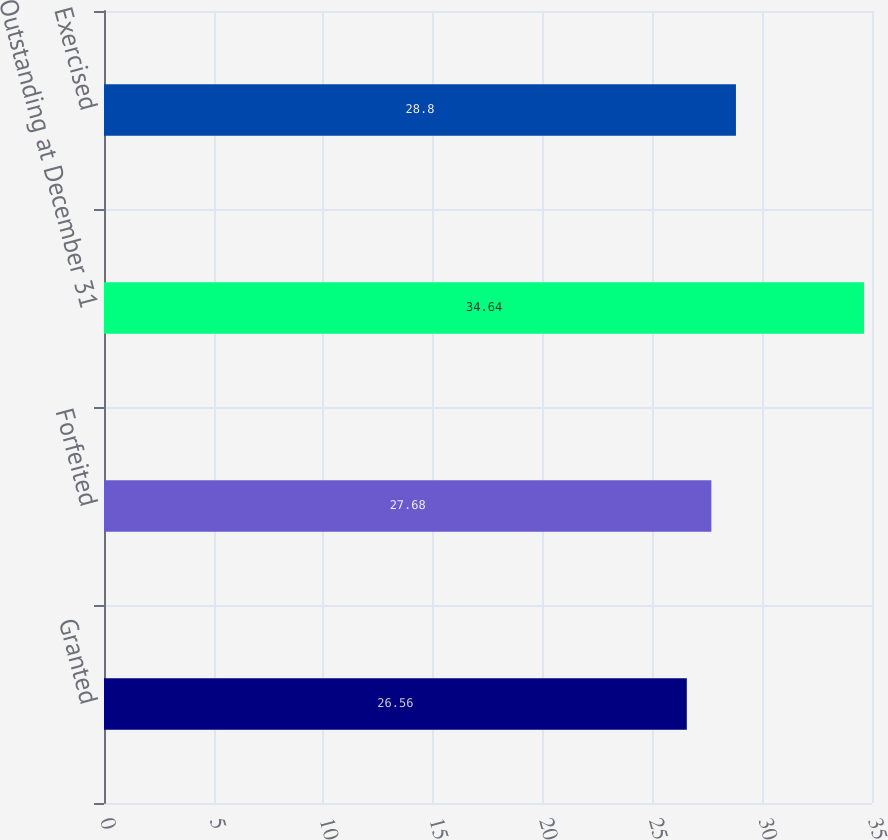Convert chart. <chart><loc_0><loc_0><loc_500><loc_500><bar_chart><fcel>Granted<fcel>Forfeited<fcel>Outstanding at December 31<fcel>Exercised<nl><fcel>26.56<fcel>27.68<fcel>34.64<fcel>28.8<nl></chart> 